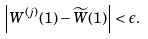<formula> <loc_0><loc_0><loc_500><loc_500>\left | W ^ { ( j ) } ( 1 ) - \widetilde { W } ( 1 ) \right | < \epsilon .</formula> 